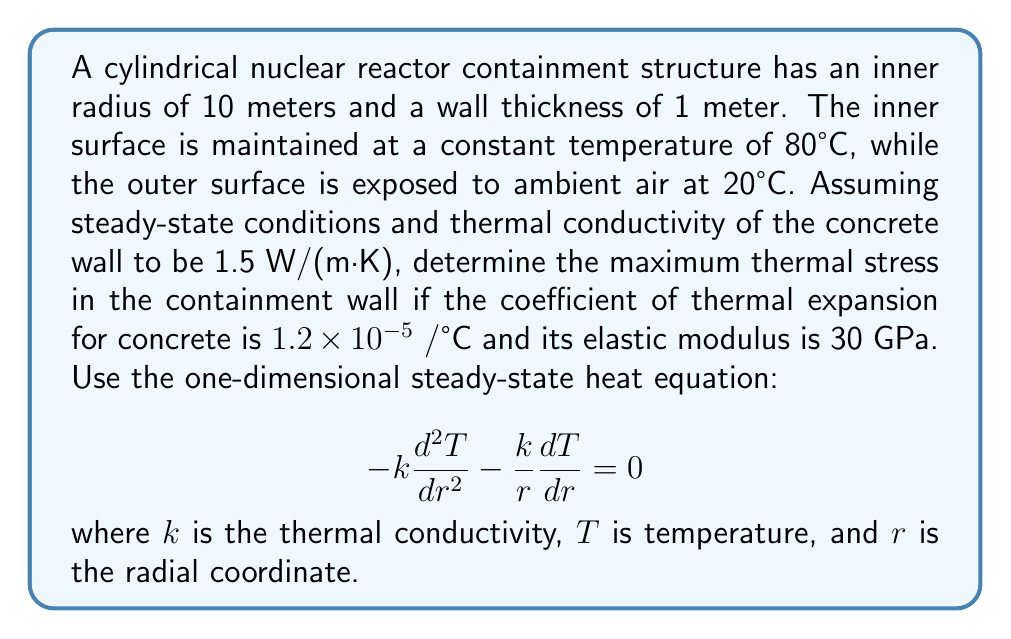Solve this math problem. Let's approach this problem step-by-step:

1) First, we need to solve the heat equation for the temperature distribution. The general solution for the steady-state heat equation in cylindrical coordinates is:

   $$T(r) = C_1 \ln(r) + C_2$$

2) Apply the boundary conditions:
   At $r = 10$ m, $T = 80°C$
   At $r = 11$ m, $T = 20°C$

3) Substituting these conditions:
   $$80 = C_1 \ln(10) + C_2$$
   $$20 = C_1 \ln(11) + C_2$$

4) Subtracting these equations:
   $$60 = C_1 (\ln(10) - \ln(11))$$
   $$C_1 = \frac{60}{\ln(10/11)} = -262.86$$

5) Substituting back:
   $$C_2 = 80 - (-262.86) \ln(10) = 685.39$$

6) So, the temperature distribution is:
   $$T(r) = -262.86 \ln(r) + 685.39$$

7) The maximum temperature difference occurs between the inner and outer surfaces:
   $$\Delta T = T(10) - T(11) = 60°C$$

8) The thermal stress is given by:
   $$\sigma = E \alpha \Delta T$$
   where $E$ is the elastic modulus and $\alpha$ is the coefficient of thermal expansion.

9) Substituting the values:
   $$\sigma = (30 \times 10^9)(1.2 \times 10^{-5})(60) = 21.6 \times 10^6 \text{ Pa} = 21.6 \text{ MPa}$$
Answer: 21.6 MPa 